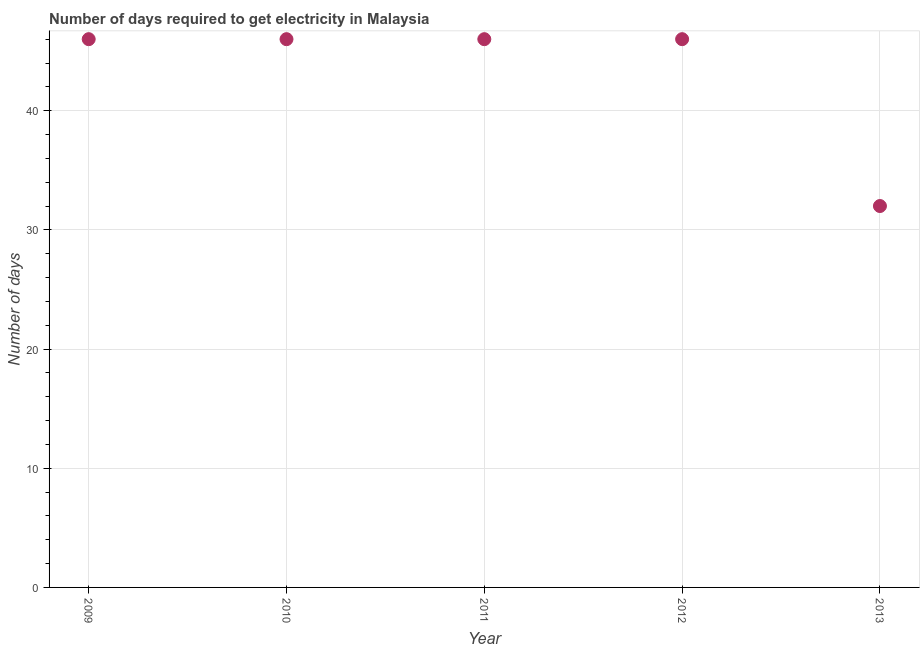What is the time to get electricity in 2010?
Make the answer very short. 46. Across all years, what is the maximum time to get electricity?
Give a very brief answer. 46. Across all years, what is the minimum time to get electricity?
Offer a terse response. 32. In which year was the time to get electricity maximum?
Keep it short and to the point. 2009. In which year was the time to get electricity minimum?
Your response must be concise. 2013. What is the sum of the time to get electricity?
Your answer should be very brief. 216. What is the difference between the time to get electricity in 2011 and 2013?
Provide a succinct answer. 14. What is the average time to get electricity per year?
Your response must be concise. 43.2. What is the ratio of the time to get electricity in 2009 to that in 2011?
Offer a terse response. 1. Is the time to get electricity in 2011 less than that in 2012?
Make the answer very short. No. Is the difference between the time to get electricity in 2009 and 2011 greater than the difference between any two years?
Offer a terse response. No. Is the sum of the time to get electricity in 2011 and 2012 greater than the maximum time to get electricity across all years?
Provide a short and direct response. Yes. What is the difference between the highest and the lowest time to get electricity?
Provide a succinct answer. 14. Does the time to get electricity monotonically increase over the years?
Provide a succinct answer. No. How many dotlines are there?
Make the answer very short. 1. Does the graph contain any zero values?
Make the answer very short. No. What is the title of the graph?
Make the answer very short. Number of days required to get electricity in Malaysia. What is the label or title of the Y-axis?
Provide a short and direct response. Number of days. What is the Number of days in 2009?
Provide a succinct answer. 46. What is the Number of days in 2010?
Give a very brief answer. 46. What is the difference between the Number of days in 2010 and 2011?
Make the answer very short. 0. What is the difference between the Number of days in 2011 and 2013?
Keep it short and to the point. 14. What is the ratio of the Number of days in 2009 to that in 2012?
Make the answer very short. 1. What is the ratio of the Number of days in 2009 to that in 2013?
Make the answer very short. 1.44. What is the ratio of the Number of days in 2010 to that in 2011?
Give a very brief answer. 1. What is the ratio of the Number of days in 2010 to that in 2013?
Provide a short and direct response. 1.44. What is the ratio of the Number of days in 2011 to that in 2013?
Your answer should be compact. 1.44. What is the ratio of the Number of days in 2012 to that in 2013?
Ensure brevity in your answer.  1.44. 